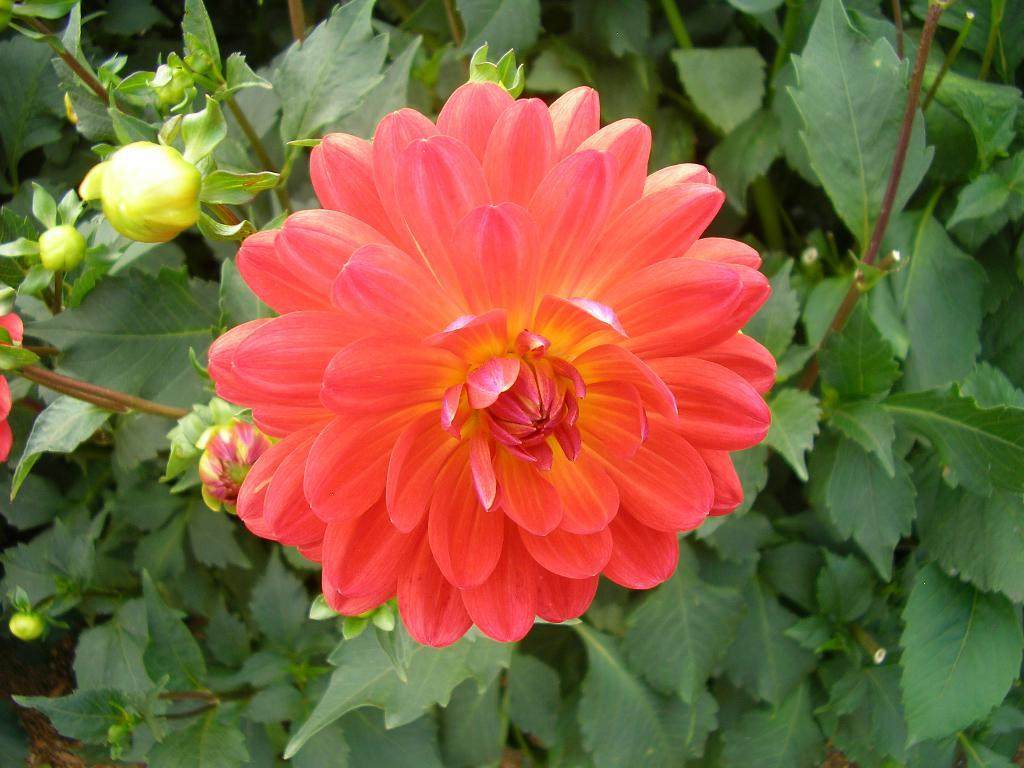What type of plant is visible in the image? There is a flower with petals in the image, which is part of a plant. What is the color of the flower in the image? The flower is dark peach in color. Are there any unopened parts of the flower visible in the image? Yes, there are flower buds in the image. What else can be seen in the image besides the flower? There are leaves in the image. How does the flower help to cover the earth in the image? The flower does not help to cover the earth in the image; it is a single flower on a plant. 